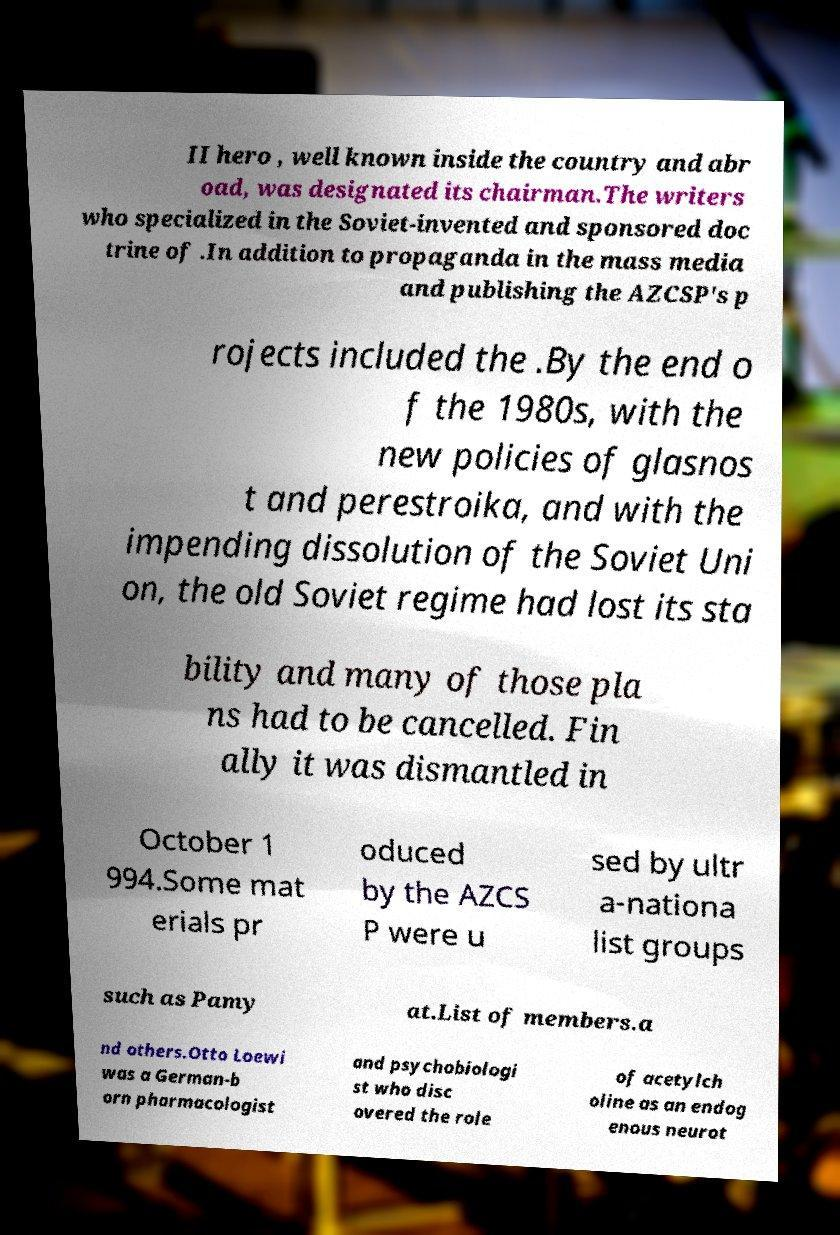Can you accurately transcribe the text from the provided image for me? II hero , well known inside the country and abr oad, was designated its chairman.The writers who specialized in the Soviet-invented and sponsored doc trine of .In addition to propaganda in the mass media and publishing the AZCSP's p rojects included the .By the end o f the 1980s, with the new policies of glasnos t and perestroika, and with the impending dissolution of the Soviet Uni on, the old Soviet regime had lost its sta bility and many of those pla ns had to be cancelled. Fin ally it was dismantled in October 1 994.Some mat erials pr oduced by the AZCS P were u sed by ultr a-nationa list groups such as Pamy at.List of members.a nd others.Otto Loewi was a German-b orn pharmacologist and psychobiologi st who disc overed the role of acetylch oline as an endog enous neurot 